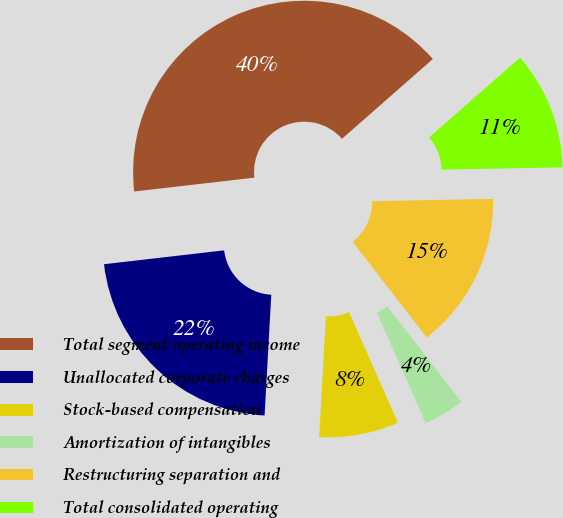Convert chart. <chart><loc_0><loc_0><loc_500><loc_500><pie_chart><fcel>Total segment operating income<fcel>Unallocated corporate charges<fcel>Stock-based compensation<fcel>Amortization of intangibles<fcel>Restructuring separation and<fcel>Total consolidated operating<nl><fcel>40.36%<fcel>22.29%<fcel>7.51%<fcel>3.86%<fcel>14.81%<fcel>11.16%<nl></chart> 